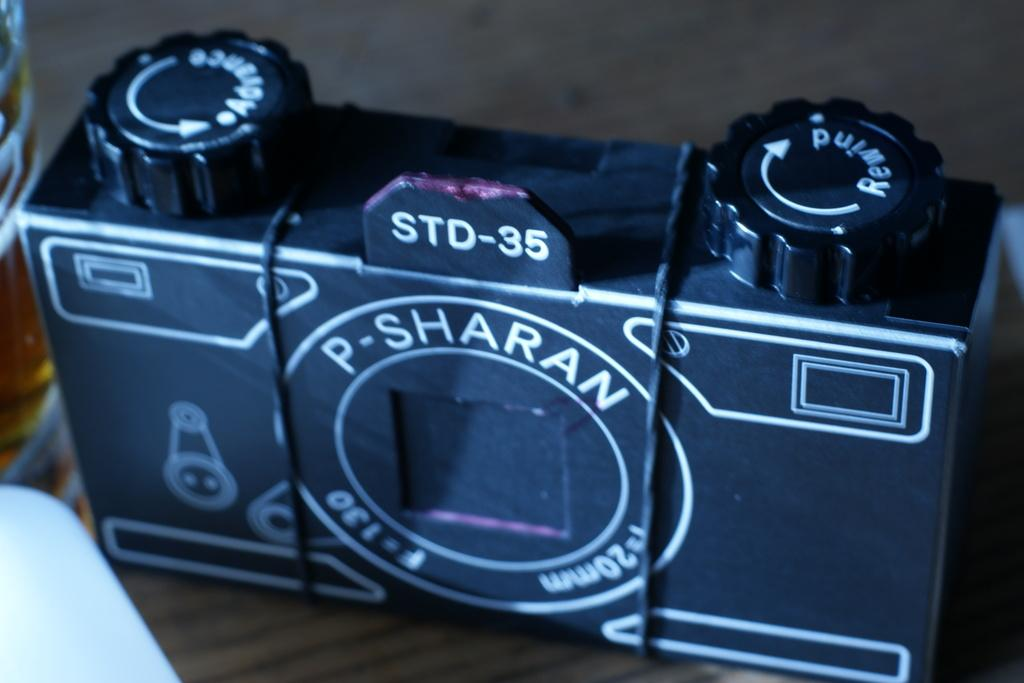<image>
Offer a succinct explanation of the picture presented. A black camera says "P-SHARAN" on the front. 